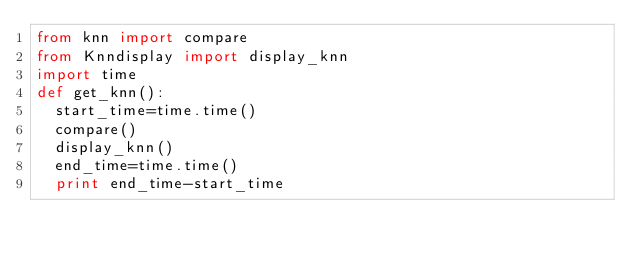Convert code to text. <code><loc_0><loc_0><loc_500><loc_500><_Python_>from knn import compare
from Knndisplay import display_knn
import time
def get_knn():
	start_time=time.time()
	compare()
	display_knn()
	end_time=time.time()
	print end_time-start_time
	</code> 